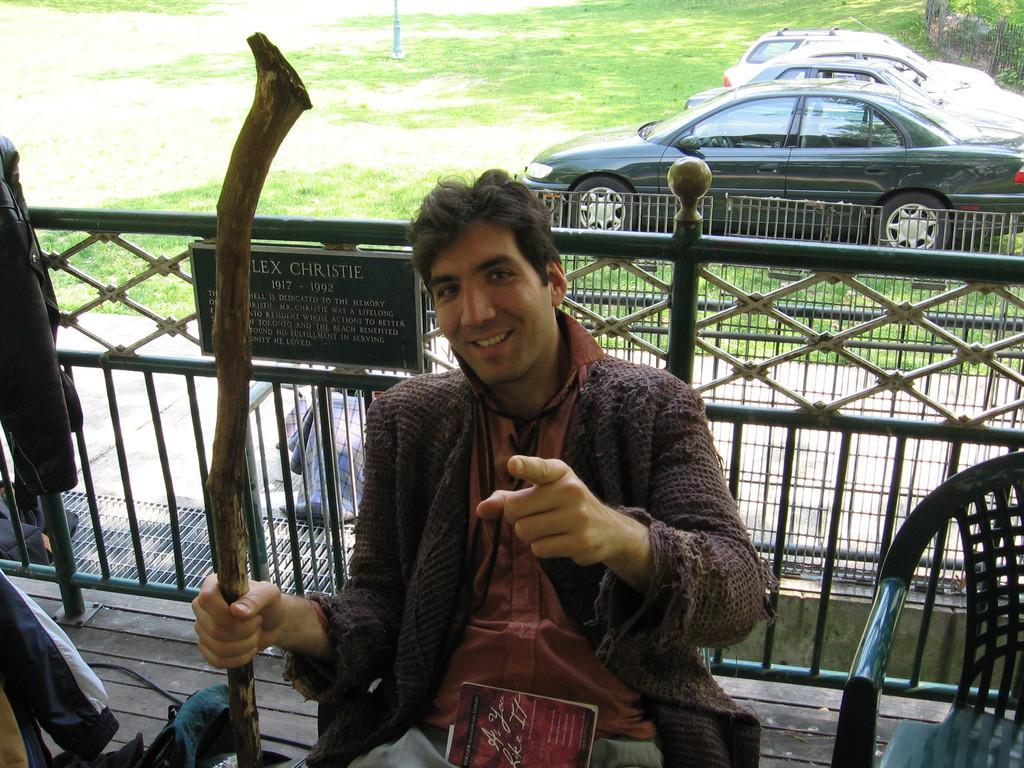What is the person in the image doing? The person is sitting in a chair. What object is the person holding? The person is holding a wooden stick. Is there another chair visible in the image? Yes, there is an empty chair beside the person. What can be seen in the background of the image? There are cars in the background of the image. What type of cheese is the person using to fly the kite in the image? There is no kite or cheese present in the image. What is the person using the wooden stick for in the image? The purpose of the wooden stick is not explicitly mentioned in the image, so we cannot definitively answer this question. 